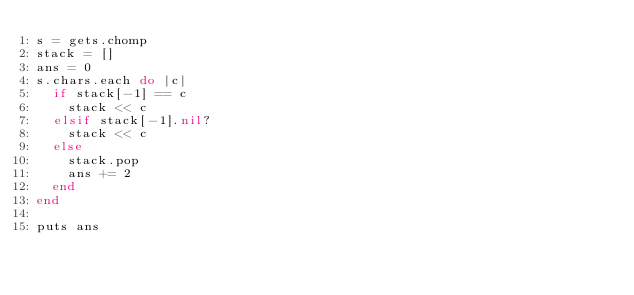Convert code to text. <code><loc_0><loc_0><loc_500><loc_500><_Ruby_>s = gets.chomp
stack = []
ans = 0
s.chars.each do |c|
  if stack[-1] == c
    stack << c
  elsif stack[-1].nil?
    stack << c
  else
    stack.pop
    ans += 2
  end
end

puts ans</code> 